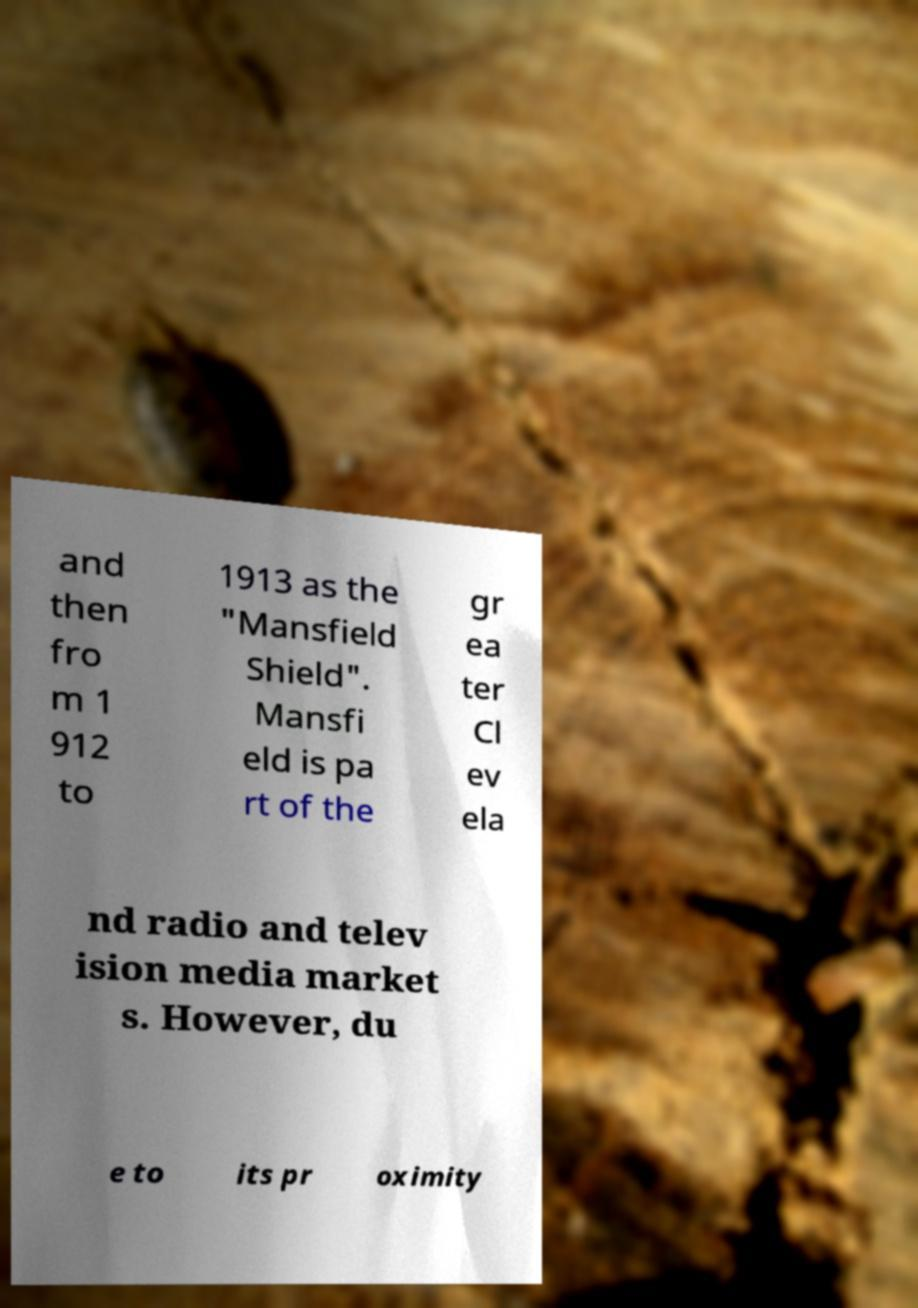Please read and relay the text visible in this image. What does it say? and then fro m 1 912 to 1913 as the "Mansfield Shield". Mansfi eld is pa rt of the gr ea ter Cl ev ela nd radio and telev ision media market s. However, du e to its pr oximity 